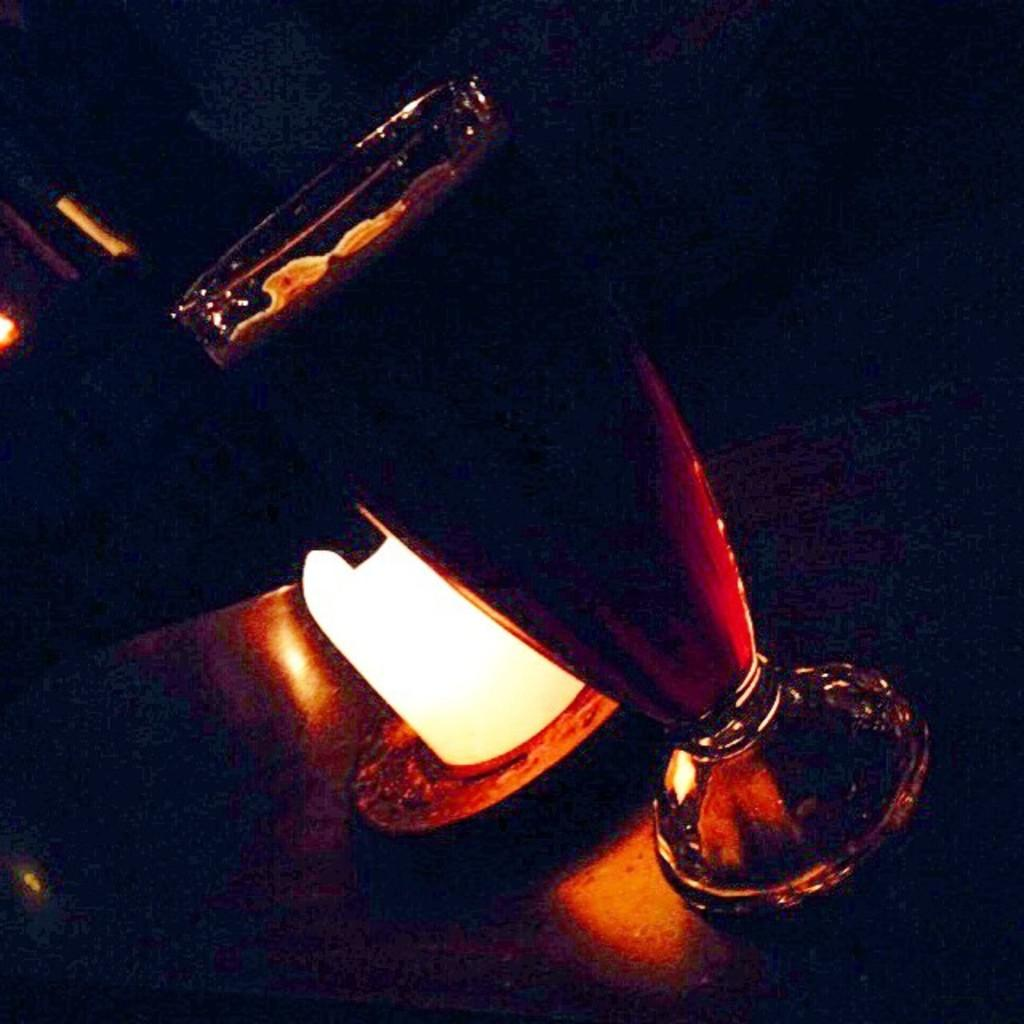What is the main object in the image? There is a wine glass in the image. Where is the wine glass located in relation to another object? The wine glass is in front of a lamp. What is present on a table in the image? There is a vessel on a table in the image. How would you describe the lighting in the image? The background of the image is dark. What type of dress is the judge wearing in the image? There is no judge or dress present in the image; it features a wine glass, a lamp, and a vessel on a table. 